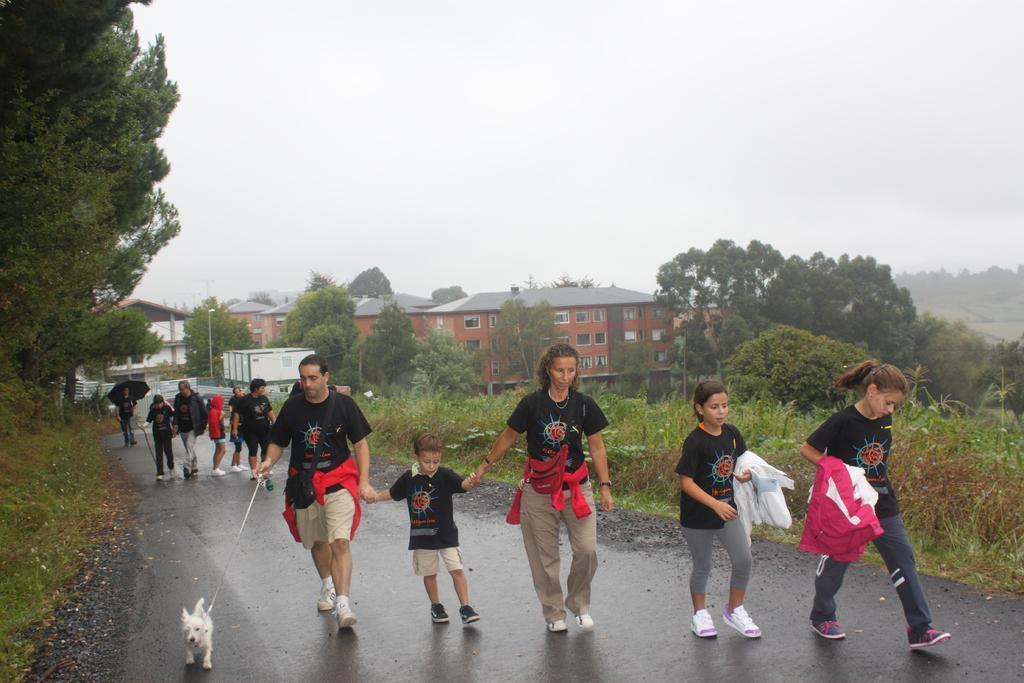Could you give a brief overview of what you see in this image? In this image I can see the group of people are walking on the road. These people are wearing the black, grey and brown color dress. I can see one person holding the chain of the dog and another person is holding the umbrella. In the background there are many trees, house and the sky. 